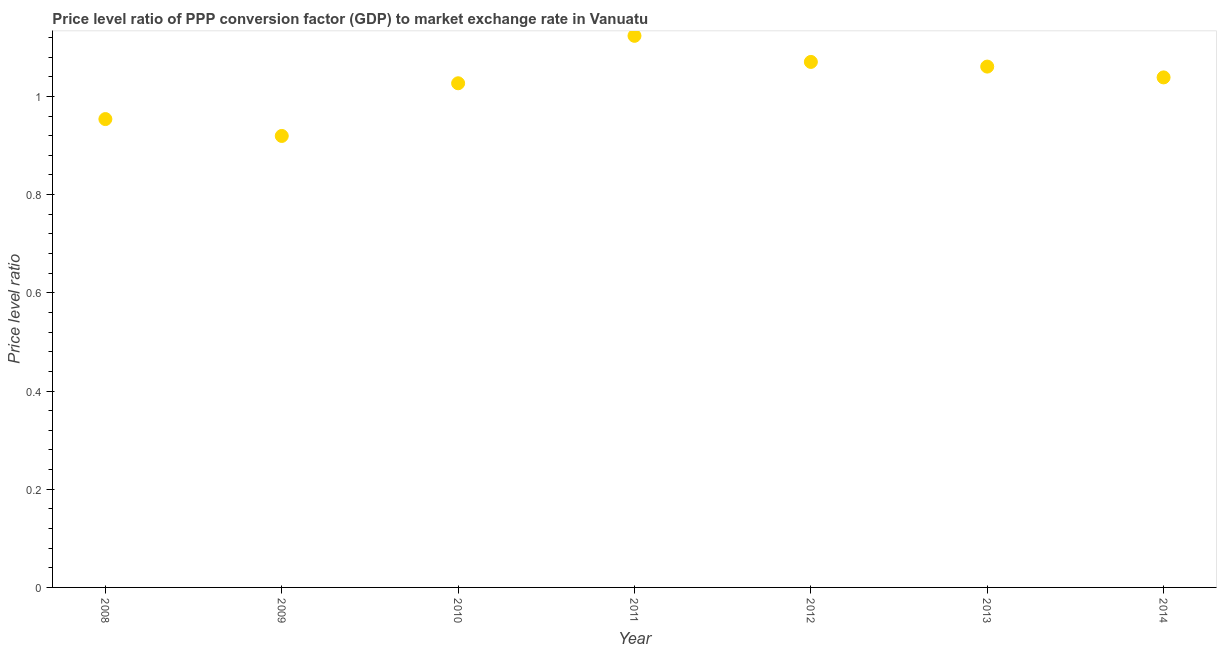What is the price level ratio in 2011?
Keep it short and to the point. 1.12. Across all years, what is the maximum price level ratio?
Provide a succinct answer. 1.12. Across all years, what is the minimum price level ratio?
Provide a short and direct response. 0.92. In which year was the price level ratio maximum?
Provide a succinct answer. 2011. In which year was the price level ratio minimum?
Give a very brief answer. 2009. What is the sum of the price level ratio?
Offer a terse response. 7.19. What is the difference between the price level ratio in 2012 and 2013?
Your answer should be compact. 0.01. What is the average price level ratio per year?
Your answer should be very brief. 1.03. What is the median price level ratio?
Ensure brevity in your answer.  1.04. What is the ratio of the price level ratio in 2008 to that in 2013?
Offer a terse response. 0.9. Is the difference between the price level ratio in 2008 and 2012 greater than the difference between any two years?
Give a very brief answer. No. What is the difference between the highest and the second highest price level ratio?
Ensure brevity in your answer.  0.05. Is the sum of the price level ratio in 2009 and 2011 greater than the maximum price level ratio across all years?
Provide a succinct answer. Yes. What is the difference between the highest and the lowest price level ratio?
Keep it short and to the point. 0.2. In how many years, is the price level ratio greater than the average price level ratio taken over all years?
Your response must be concise. 4. What is the title of the graph?
Offer a terse response. Price level ratio of PPP conversion factor (GDP) to market exchange rate in Vanuatu. What is the label or title of the Y-axis?
Your response must be concise. Price level ratio. What is the Price level ratio in 2008?
Ensure brevity in your answer.  0.95. What is the Price level ratio in 2009?
Your answer should be very brief. 0.92. What is the Price level ratio in 2010?
Ensure brevity in your answer.  1.03. What is the Price level ratio in 2011?
Provide a succinct answer. 1.12. What is the Price level ratio in 2012?
Ensure brevity in your answer.  1.07. What is the Price level ratio in 2013?
Your answer should be very brief. 1.06. What is the Price level ratio in 2014?
Give a very brief answer. 1.04. What is the difference between the Price level ratio in 2008 and 2009?
Your answer should be very brief. 0.03. What is the difference between the Price level ratio in 2008 and 2010?
Keep it short and to the point. -0.07. What is the difference between the Price level ratio in 2008 and 2011?
Ensure brevity in your answer.  -0.17. What is the difference between the Price level ratio in 2008 and 2012?
Make the answer very short. -0.12. What is the difference between the Price level ratio in 2008 and 2013?
Your answer should be compact. -0.11. What is the difference between the Price level ratio in 2008 and 2014?
Your answer should be very brief. -0.08. What is the difference between the Price level ratio in 2009 and 2010?
Keep it short and to the point. -0.11. What is the difference between the Price level ratio in 2009 and 2011?
Provide a succinct answer. -0.2. What is the difference between the Price level ratio in 2009 and 2012?
Offer a very short reply. -0.15. What is the difference between the Price level ratio in 2009 and 2013?
Your answer should be very brief. -0.14. What is the difference between the Price level ratio in 2009 and 2014?
Offer a very short reply. -0.12. What is the difference between the Price level ratio in 2010 and 2011?
Offer a very short reply. -0.1. What is the difference between the Price level ratio in 2010 and 2012?
Keep it short and to the point. -0.04. What is the difference between the Price level ratio in 2010 and 2013?
Your answer should be very brief. -0.03. What is the difference between the Price level ratio in 2010 and 2014?
Provide a short and direct response. -0.01. What is the difference between the Price level ratio in 2011 and 2012?
Your answer should be very brief. 0.05. What is the difference between the Price level ratio in 2011 and 2013?
Your answer should be compact. 0.06. What is the difference between the Price level ratio in 2011 and 2014?
Offer a terse response. 0.08. What is the difference between the Price level ratio in 2012 and 2013?
Ensure brevity in your answer.  0.01. What is the difference between the Price level ratio in 2012 and 2014?
Ensure brevity in your answer.  0.03. What is the difference between the Price level ratio in 2013 and 2014?
Provide a short and direct response. 0.02. What is the ratio of the Price level ratio in 2008 to that in 2010?
Ensure brevity in your answer.  0.93. What is the ratio of the Price level ratio in 2008 to that in 2011?
Offer a terse response. 0.85. What is the ratio of the Price level ratio in 2008 to that in 2012?
Provide a short and direct response. 0.89. What is the ratio of the Price level ratio in 2008 to that in 2013?
Provide a short and direct response. 0.9. What is the ratio of the Price level ratio in 2008 to that in 2014?
Your answer should be very brief. 0.92. What is the ratio of the Price level ratio in 2009 to that in 2010?
Give a very brief answer. 0.9. What is the ratio of the Price level ratio in 2009 to that in 2011?
Your answer should be compact. 0.82. What is the ratio of the Price level ratio in 2009 to that in 2012?
Give a very brief answer. 0.86. What is the ratio of the Price level ratio in 2009 to that in 2013?
Provide a succinct answer. 0.87. What is the ratio of the Price level ratio in 2009 to that in 2014?
Your answer should be compact. 0.89. What is the ratio of the Price level ratio in 2010 to that in 2011?
Offer a terse response. 0.91. What is the ratio of the Price level ratio in 2010 to that in 2012?
Offer a very short reply. 0.96. What is the ratio of the Price level ratio in 2011 to that in 2013?
Offer a very short reply. 1.06. What is the ratio of the Price level ratio in 2011 to that in 2014?
Your answer should be compact. 1.08. What is the ratio of the Price level ratio in 2012 to that in 2013?
Offer a terse response. 1.01. 